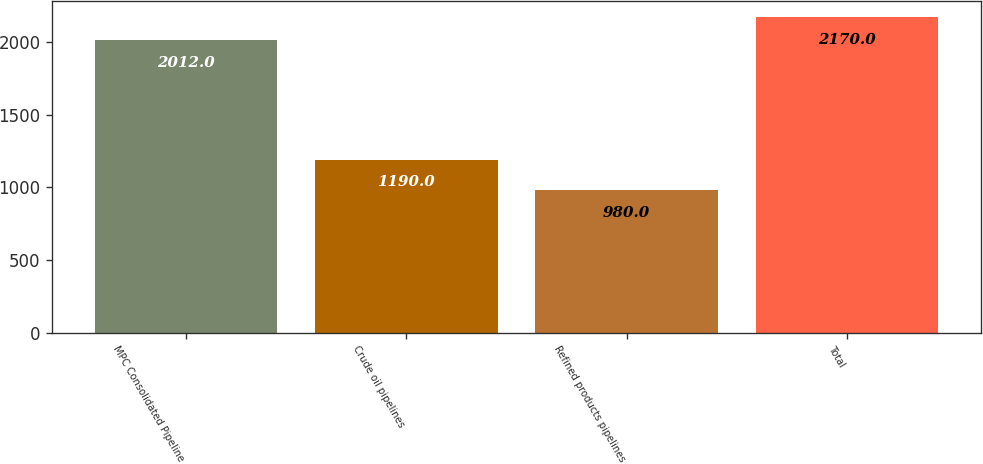<chart> <loc_0><loc_0><loc_500><loc_500><bar_chart><fcel>MPC Consolidated Pipeline<fcel>Crude oil pipelines<fcel>Refined products pipelines<fcel>Total<nl><fcel>2012<fcel>1190<fcel>980<fcel>2170<nl></chart> 